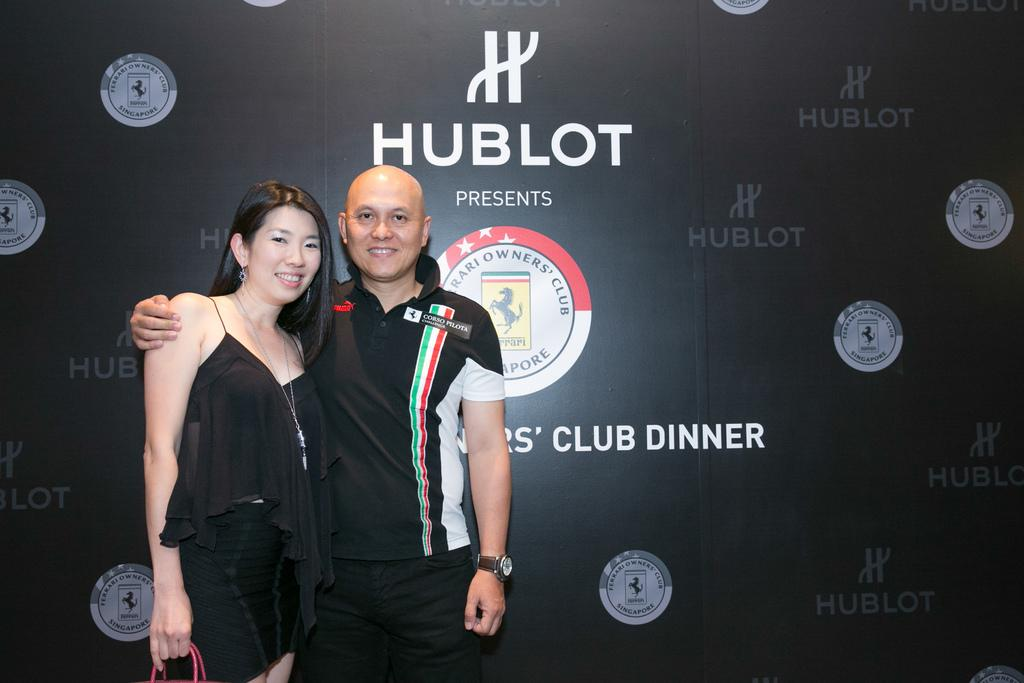<image>
Relay a brief, clear account of the picture shown. The people here are hosting a club dinner 